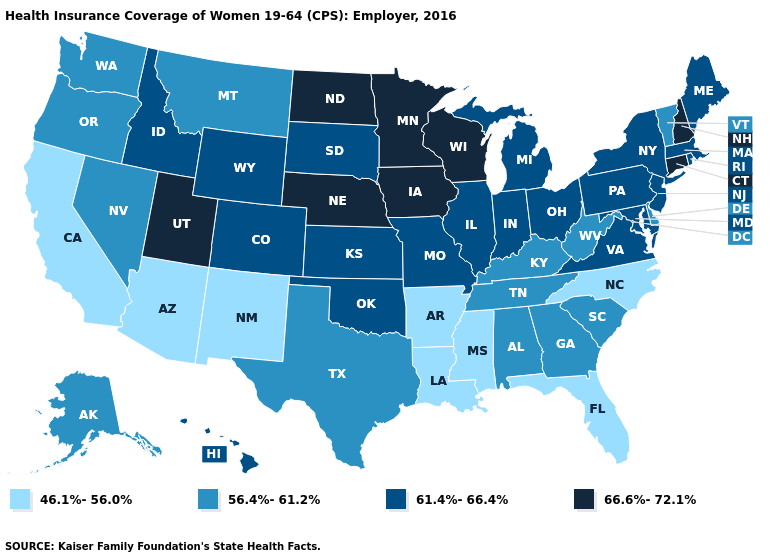Name the states that have a value in the range 61.4%-66.4%?
Short answer required. Colorado, Hawaii, Idaho, Illinois, Indiana, Kansas, Maine, Maryland, Massachusetts, Michigan, Missouri, New Jersey, New York, Ohio, Oklahoma, Pennsylvania, Rhode Island, South Dakota, Virginia, Wyoming. Among the states that border Colorado , which have the highest value?
Be succinct. Nebraska, Utah. Which states hav the highest value in the MidWest?
Answer briefly. Iowa, Minnesota, Nebraska, North Dakota, Wisconsin. Does New York have the lowest value in the Northeast?
Keep it brief. No. Name the states that have a value in the range 46.1%-56.0%?
Quick response, please. Arizona, Arkansas, California, Florida, Louisiana, Mississippi, New Mexico, North Carolina. Name the states that have a value in the range 61.4%-66.4%?
Write a very short answer. Colorado, Hawaii, Idaho, Illinois, Indiana, Kansas, Maine, Maryland, Massachusetts, Michigan, Missouri, New Jersey, New York, Ohio, Oklahoma, Pennsylvania, Rhode Island, South Dakota, Virginia, Wyoming. Among the states that border Oregon , does Nevada have the lowest value?
Write a very short answer. No. What is the value of Wyoming?
Concise answer only. 61.4%-66.4%. Name the states that have a value in the range 66.6%-72.1%?
Quick response, please. Connecticut, Iowa, Minnesota, Nebraska, New Hampshire, North Dakota, Utah, Wisconsin. What is the lowest value in the MidWest?
Write a very short answer. 61.4%-66.4%. Does Minnesota have the lowest value in the MidWest?
Short answer required. No. Among the states that border Washington , which have the highest value?
Be succinct. Idaho. Name the states that have a value in the range 56.4%-61.2%?
Keep it brief. Alabama, Alaska, Delaware, Georgia, Kentucky, Montana, Nevada, Oregon, South Carolina, Tennessee, Texas, Vermont, Washington, West Virginia. How many symbols are there in the legend?
Keep it brief. 4. Does Missouri have the same value as Mississippi?
Concise answer only. No. 